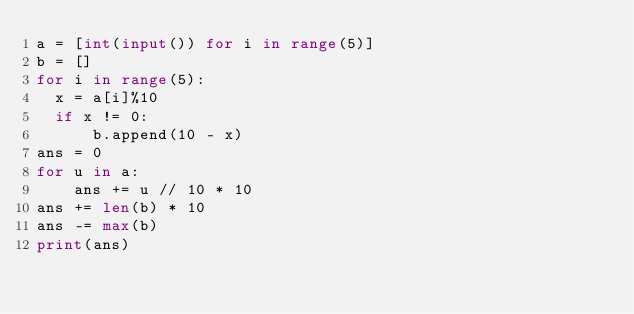<code> <loc_0><loc_0><loc_500><loc_500><_Python_>a = [int(input()) for i in range(5)]
b = []
for i in range(5):
	x = a[i]%10
	if x != 0:
	    b.append(10 - x)
ans = 0
for u in a:
    ans += u // 10 * 10
ans += len(b) * 10
ans -= max(b)
print(ans) </code> 